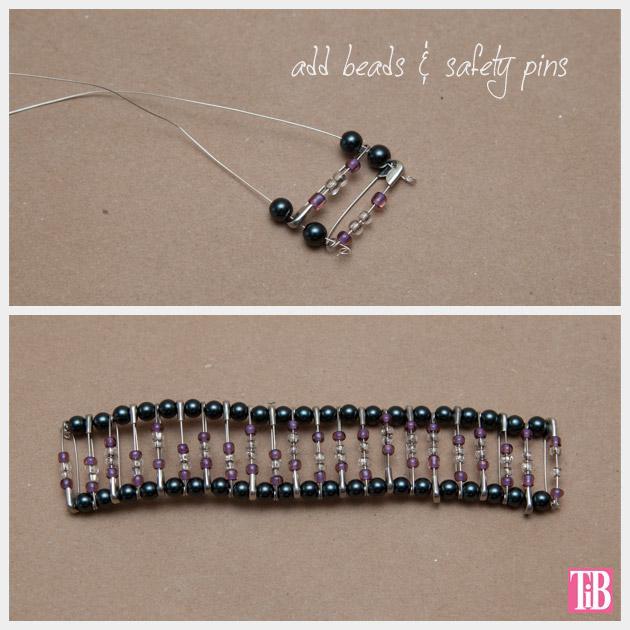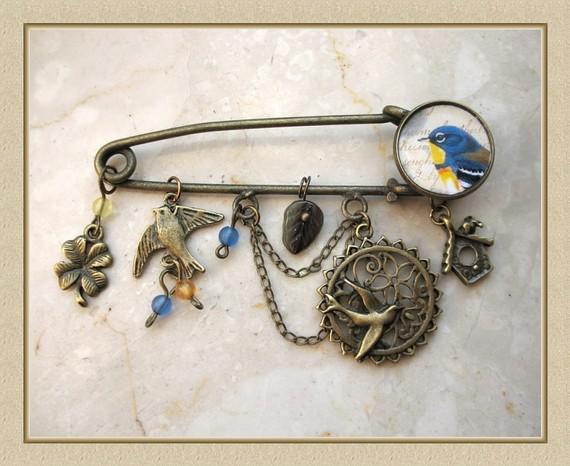The first image is the image on the left, the second image is the image on the right. Evaluate the accuracy of this statement regarding the images: "The right image shows only one decorated pin.". Is it true? Answer yes or no. Yes. 